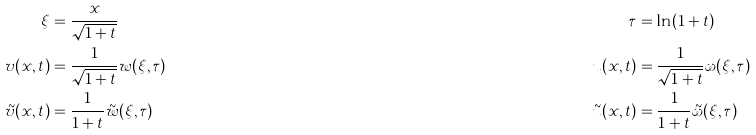Convert formula to latex. <formula><loc_0><loc_0><loc_500><loc_500>\xi & = \frac { x } { \sqrt { 1 + t } } & \tau & = \ln ( 1 + t ) \\ v ( x , t ) & = \frac { 1 } { \sqrt { 1 + t } } w ( \xi , \tau ) & u ( x , t ) & = \frac { 1 } { \sqrt { 1 + t } } \omega ( \xi , \tau ) \\ \tilde { v } ( x , t ) & = \frac { 1 } { 1 + t } \tilde { w } ( \xi , \tau ) & \tilde { u } ( x , t ) & = \frac { 1 } { 1 + t } \tilde { \omega } ( \xi , \tau )</formula> 